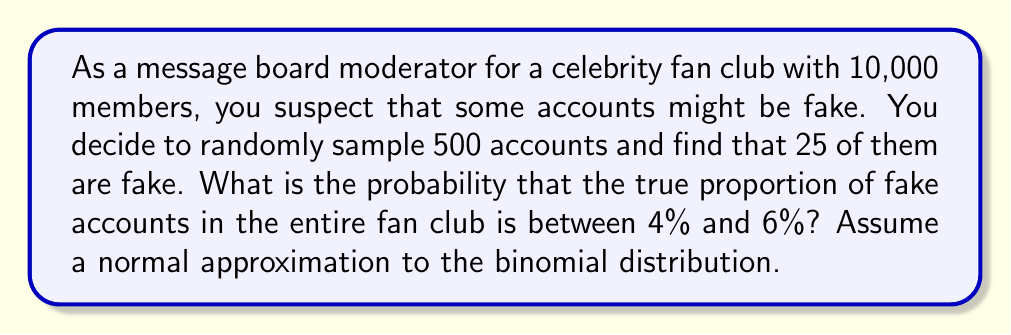Teach me how to tackle this problem. Let's approach this step-by-step:

1) First, we need to calculate the sample proportion of fake accounts:
   $\hat{p} = \frac{25}{500} = 0.05$ or 5%

2) The standard error of the proportion is:
   $SE = \sqrt{\frac{\hat{p}(1-\hat{p})}{n}} = \sqrt{\frac{0.05(1-0.05)}{500}} = 0.00975$

3) We want to find $P(0.04 < p < 0.06)$, where $p$ is the true proportion of fake accounts.

4) We can standardize this interval:
   $z_{lower} = \frac{0.04 - 0.05}{0.00975} = -1.026$
   $z_{upper} = \frac{0.06 - 0.05}{0.00975} = 1.026$

5) Now we need to find $P(-1.026 < Z < 1.026)$, where Z is a standard normal variable.

6) Using the standard normal distribution table or a calculator:
   $P(Z < 1.026) = 0.8476$
   $P(Z < -1.026) = 0.1524$

7) Therefore, $P(-1.026 < Z < 1.026) = 0.8476 - 0.1524 = 0.6952$

Thus, there is approximately a 69.52% probability that the true proportion of fake accounts in the entire fan club is between 4% and 6%.
Answer: 0.6952 or 69.52% 